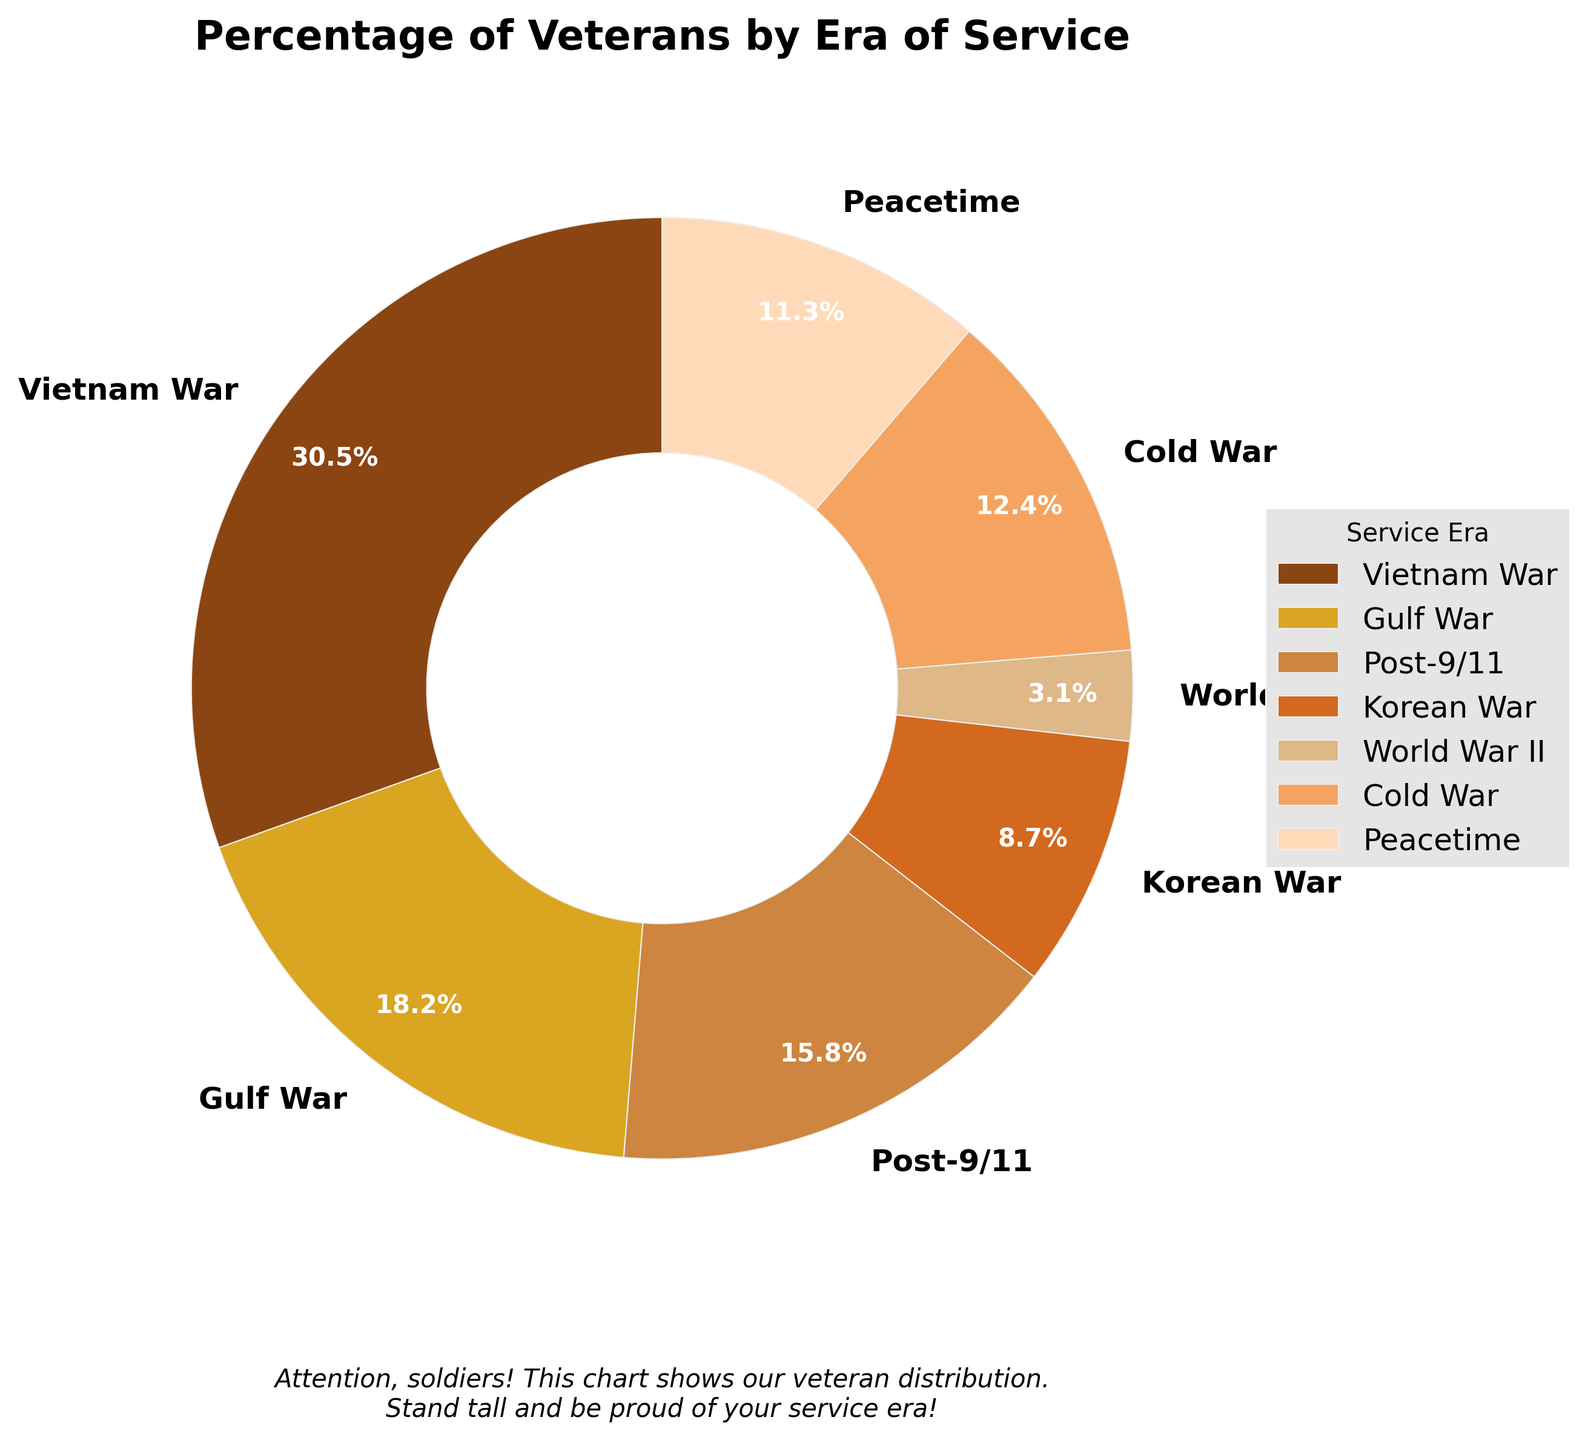Which era of service has the highest percentage of veterans? By looking at the pie chart, the era with the largest wedge size represents the highest percentage of veterans. In this chart, the Vietnam War era has the highest percentage.
Answer: Vietnam War What is the total percentage of veterans who served in the Gulf War and the Cold War? To find the total percentage of veterans who served in both the Gulf War and the Cold War, add their individual percentages: 18.2% (Gulf War) + 12.4% (Cold War) = 30.6%.
Answer: 30.6% Which era of service has the smallest percentage of veterans, and what is that percentage? By examining the smallest wedge in the pie chart, we can identify that the World War II era has the smallest percentage of veterans.
Answer: World War II, 3.1% Are there more veterans from the Post-9/11 era or the Peacetime era? Compare the wedges for the Post-9/11 and Peacetime eras in the pie chart. The Post-9/11 era has 15.8%, and the Peacetime era has 11.3%. Therefore, there are more veterans from the Post-9/11 era.
Answer: Post-9/11 era How much greater is the percentage of Vietnam War veterans compared to Korean War veterans? Subtract the percentage of Korean War veterans from the percentage of Vietnam War veterans: 30.5% - 8.7% = 21.8%.
Answer: 21.8% What is the average percentage of veterans from World War II, Korean War, and Cold War eras? Add the percentages of these three eras and divide by the number of eras: (3.1% + 8.7% + 12.4%) / 3 = 8.0667%.
Answer: 8.07% Which era of service represented by the light brown slice in the pie chart? By matching the color to the pie chart, the light brown slice corresponds to the Post-9/11 era.
Answer: Post-9/11 Is the percentage of Vietnam War veterans more than double that of the Peacetime veterans? Double the percentage of Peacetime veterans: 11.3% * 2 = 22.6%. Compare this with the Vietnam War veterans' percentage: 30.5% > 22.6% indicates it is more than double.
Answer: Yes What is the combined percentage of veterans who served either in the Vietnam War or the Post-9/11 era? Adding the percentages of Vietnam War and Post-9/11 era: 30.5% + 15.8% = 46.3%.
Answer: 46.3% 